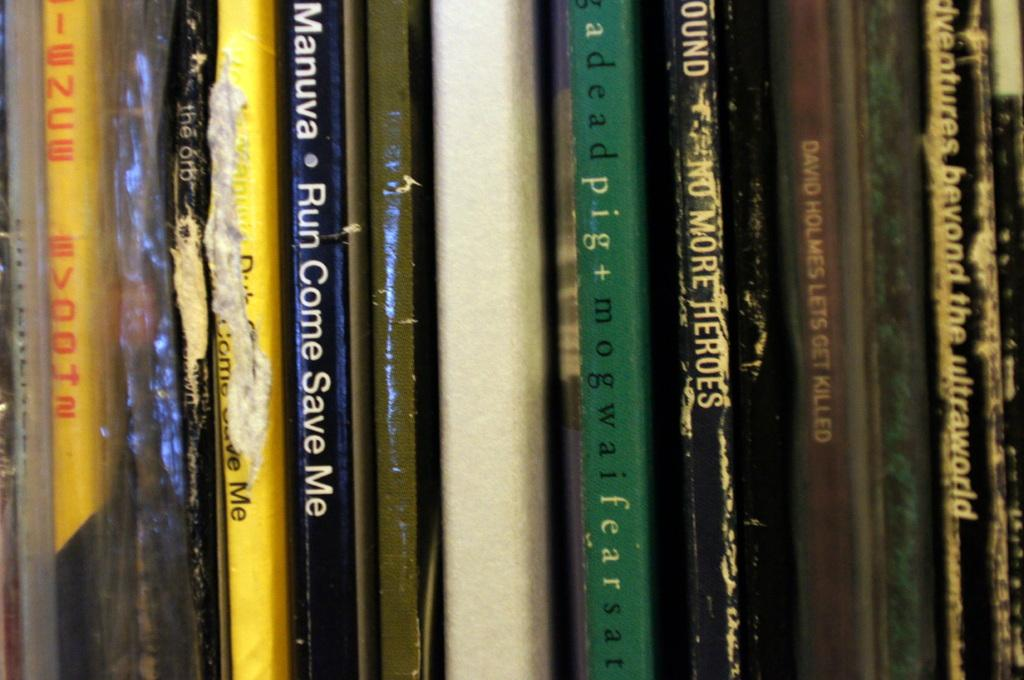<image>
Provide a brief description of the given image. A range of many books in a bookcase such as Manuva . Run come save me, adventures beyond the ultraworld etc. 